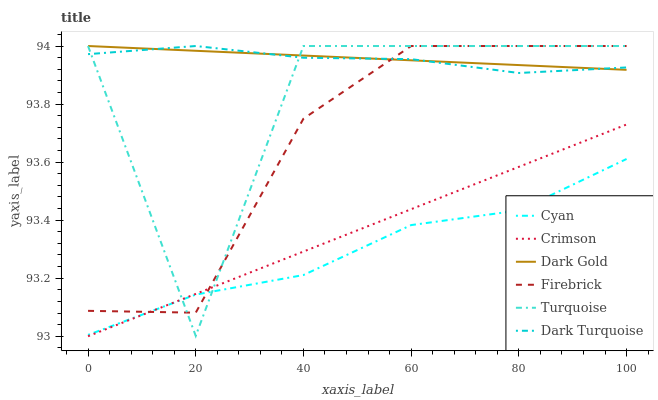Does Cyan have the minimum area under the curve?
Answer yes or no. Yes. Does Dark Gold have the maximum area under the curve?
Answer yes or no. Yes. Does Dark Turquoise have the minimum area under the curve?
Answer yes or no. No. Does Dark Turquoise have the maximum area under the curve?
Answer yes or no. No. Is Crimson the smoothest?
Answer yes or no. Yes. Is Turquoise the roughest?
Answer yes or no. Yes. Is Dark Gold the smoothest?
Answer yes or no. No. Is Dark Gold the roughest?
Answer yes or no. No. Does Dark Turquoise have the lowest value?
Answer yes or no. No. Does Firebrick have the highest value?
Answer yes or no. Yes. Does Crimson have the highest value?
Answer yes or no. No. Is Cyan less than Dark Gold?
Answer yes or no. Yes. Is Dark Gold greater than Cyan?
Answer yes or no. Yes. Does Crimson intersect Turquoise?
Answer yes or no. Yes. Is Crimson less than Turquoise?
Answer yes or no. No. Is Crimson greater than Turquoise?
Answer yes or no. No. Does Cyan intersect Dark Gold?
Answer yes or no. No. 